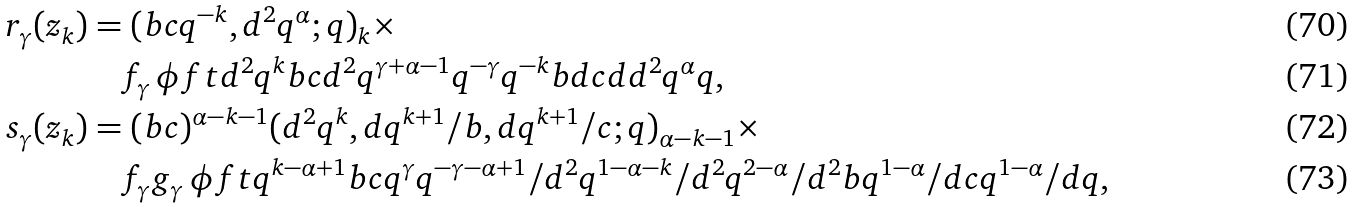Convert formula to latex. <formula><loc_0><loc_0><loc_500><loc_500>r _ { \gamma } ( z _ { k } ) & = ( b c q ^ { - k } , d ^ { 2 } q ^ { \alpha } ; q ) _ { k } \times \\ & \quad f _ { \gamma } \, \phi f t { d ^ { 2 } q ^ { k } } { b c d ^ { 2 } q ^ { \gamma + \alpha - 1 } } { q ^ { - \gamma } } { q ^ { - k } } { b d } { c d } { d ^ { 2 } q ^ { \alpha } } { q } , \\ s _ { \gamma } ( z _ { k } ) & = ( b c ) ^ { \alpha - k - 1 } ( d ^ { 2 } q ^ { k } , d q ^ { k + 1 } / b , d q ^ { k + 1 } / c ; q ) _ { \alpha - k - 1 } \times \\ & \quad f _ { \gamma } g _ { \gamma } \, \phi f t { q ^ { k - \alpha + 1 } } { b c q ^ { \gamma } } { q ^ { - \gamma - \alpha + 1 } / d ^ { 2 } } { q ^ { 1 - \alpha - k } / d ^ { 2 } } { q ^ { 2 - \alpha } / d ^ { 2 } } { b q ^ { 1 - \alpha } / d } { c q ^ { 1 - \alpha } / d } { q } ,</formula> 